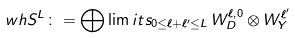Convert formula to latex. <formula><loc_0><loc_0><loc_500><loc_500>\ w h { S } ^ { L } \colon = \bigoplus \lim i t s _ { 0 \leq \ell + \ell ^ { \prime } \leq L } \, W ^ { \ell , 0 } _ { D } \otimes W ^ { \ell ^ { \prime } } _ { Y }</formula> 